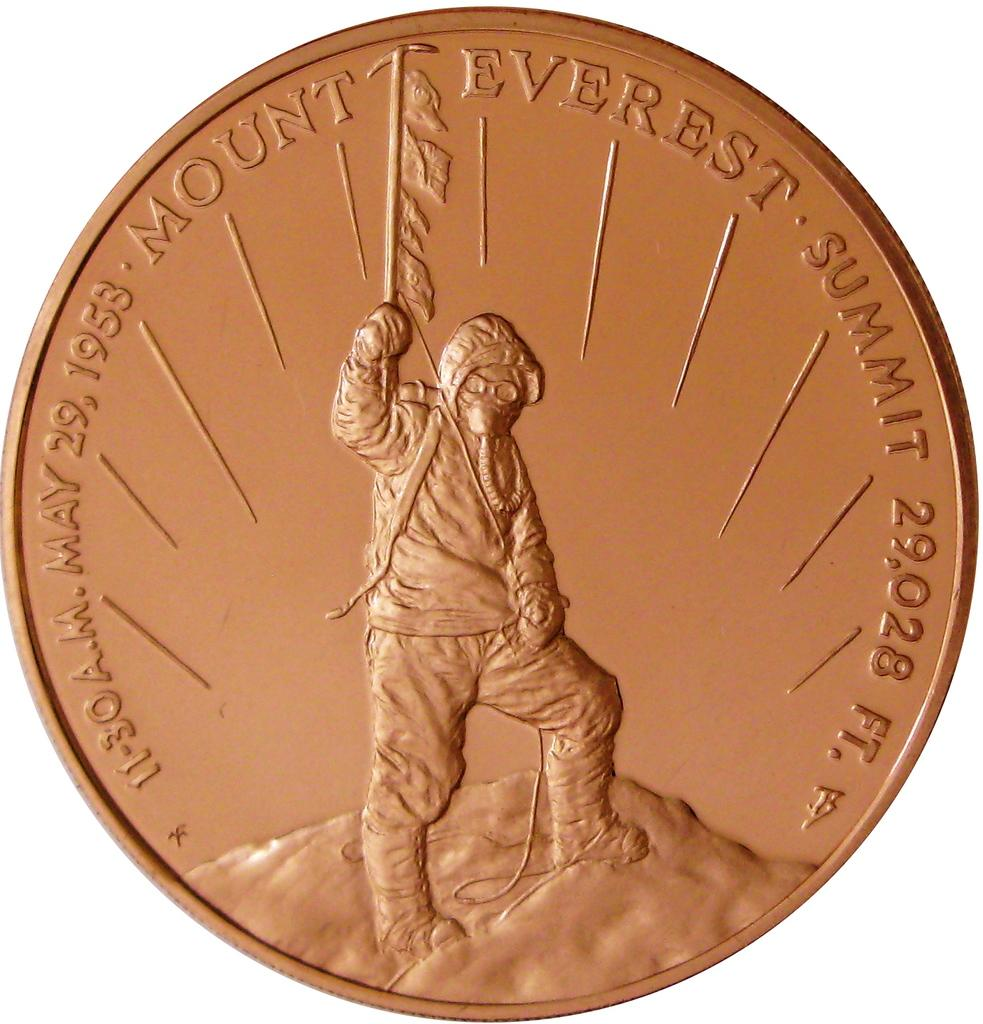<image>
Give a short and clear explanation of the subsequent image. A coin that says Mount Everest Summit and has the elevation on it. 